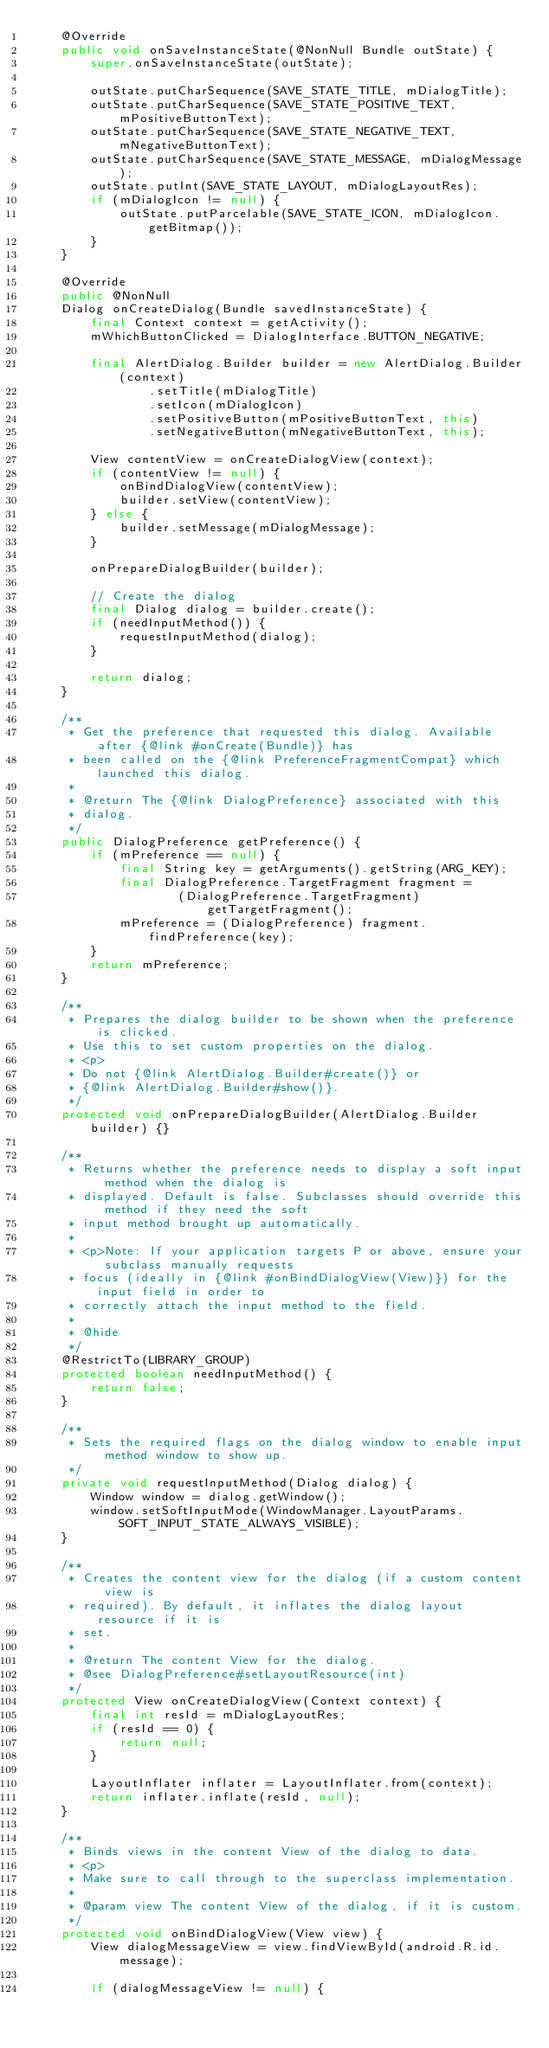<code> <loc_0><loc_0><loc_500><loc_500><_Java_>    @Override
    public void onSaveInstanceState(@NonNull Bundle outState) {
        super.onSaveInstanceState(outState);

        outState.putCharSequence(SAVE_STATE_TITLE, mDialogTitle);
        outState.putCharSequence(SAVE_STATE_POSITIVE_TEXT, mPositiveButtonText);
        outState.putCharSequence(SAVE_STATE_NEGATIVE_TEXT, mNegativeButtonText);
        outState.putCharSequence(SAVE_STATE_MESSAGE, mDialogMessage);
        outState.putInt(SAVE_STATE_LAYOUT, mDialogLayoutRes);
        if (mDialogIcon != null) {
            outState.putParcelable(SAVE_STATE_ICON, mDialogIcon.getBitmap());
        }
    }

    @Override
    public @NonNull
    Dialog onCreateDialog(Bundle savedInstanceState) {
        final Context context = getActivity();
        mWhichButtonClicked = DialogInterface.BUTTON_NEGATIVE;

        final AlertDialog.Builder builder = new AlertDialog.Builder(context)
                .setTitle(mDialogTitle)
                .setIcon(mDialogIcon)
                .setPositiveButton(mPositiveButtonText, this)
                .setNegativeButton(mNegativeButtonText, this);

        View contentView = onCreateDialogView(context);
        if (contentView != null) {
            onBindDialogView(contentView);
            builder.setView(contentView);
        } else {
            builder.setMessage(mDialogMessage);
        }

        onPrepareDialogBuilder(builder);

        // Create the dialog
        final Dialog dialog = builder.create();
        if (needInputMethod()) {
            requestInputMethod(dialog);
        }

        return dialog;
    }

    /**
     * Get the preference that requested this dialog. Available after {@link #onCreate(Bundle)} has
     * been called on the {@link PreferenceFragmentCompat} which launched this dialog.
     *
     * @return The {@link DialogPreference} associated with this
     * dialog.
     */
    public DialogPreference getPreference() {
        if (mPreference == null) {
            final String key = getArguments().getString(ARG_KEY);
            final DialogPreference.TargetFragment fragment =
                    (DialogPreference.TargetFragment) getTargetFragment();
            mPreference = (DialogPreference) fragment.findPreference(key);
        }
        return mPreference;
    }

    /**
     * Prepares the dialog builder to be shown when the preference is clicked.
     * Use this to set custom properties on the dialog.
     * <p>
     * Do not {@link AlertDialog.Builder#create()} or
     * {@link AlertDialog.Builder#show()}.
     */
    protected void onPrepareDialogBuilder(AlertDialog.Builder builder) {}

    /**
     * Returns whether the preference needs to display a soft input method when the dialog is
     * displayed. Default is false. Subclasses should override this method if they need the soft
     * input method brought up automatically.
     *
     * <p>Note: If your application targets P or above, ensure your subclass manually requests
     * focus (ideally in {@link #onBindDialogView(View)}) for the input field in order to
     * correctly attach the input method to the field.
     *
     * @hide
     */
    @RestrictTo(LIBRARY_GROUP)
    protected boolean needInputMethod() {
        return false;
    }

    /**
     * Sets the required flags on the dialog window to enable input method window to show up.
     */
    private void requestInputMethod(Dialog dialog) {
        Window window = dialog.getWindow();
        window.setSoftInputMode(WindowManager.LayoutParams.SOFT_INPUT_STATE_ALWAYS_VISIBLE);
    }

    /**
     * Creates the content view for the dialog (if a custom content view is
     * required). By default, it inflates the dialog layout resource if it is
     * set.
     *
     * @return The content View for the dialog.
     * @see DialogPreference#setLayoutResource(int)
     */
    protected View onCreateDialogView(Context context) {
        final int resId = mDialogLayoutRes;
        if (resId == 0) {
            return null;
        }

        LayoutInflater inflater = LayoutInflater.from(context);
        return inflater.inflate(resId, null);
    }

    /**
     * Binds views in the content View of the dialog to data.
     * <p>
     * Make sure to call through to the superclass implementation.
     *
     * @param view The content View of the dialog, if it is custom.
     */
    protected void onBindDialogView(View view) {
        View dialogMessageView = view.findViewById(android.R.id.message);

        if (dialogMessageView != null) {</code> 